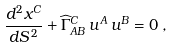<formula> <loc_0><loc_0><loc_500><loc_500>\frac { d ^ { 2 } x ^ { C } } { d S ^ { \, 2 } } + \widehat { \Gamma } _ { A B } ^ { C } \, u ^ { A } \, u ^ { B } = 0 \, ,</formula> 